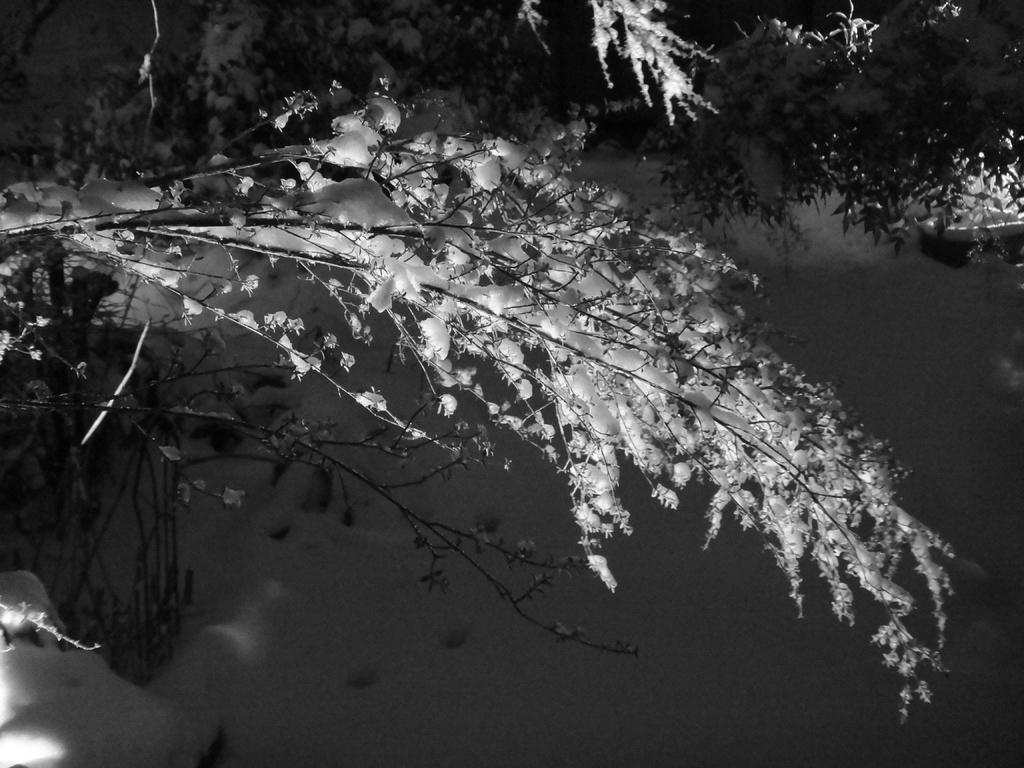In one or two sentences, can you explain what this image depicts? In this image I can see trees, background I can see sky and the image is in black and white. 